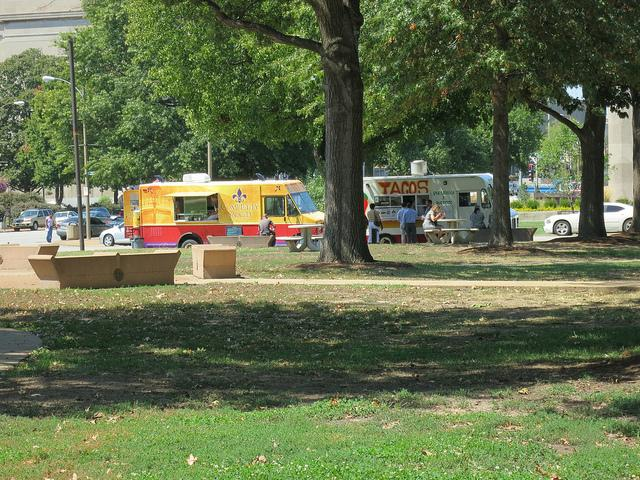What is the yellow truck doing?

Choices:
A) transporting goods
B) receiving donation
C) mobile library
D) selling food selling food 